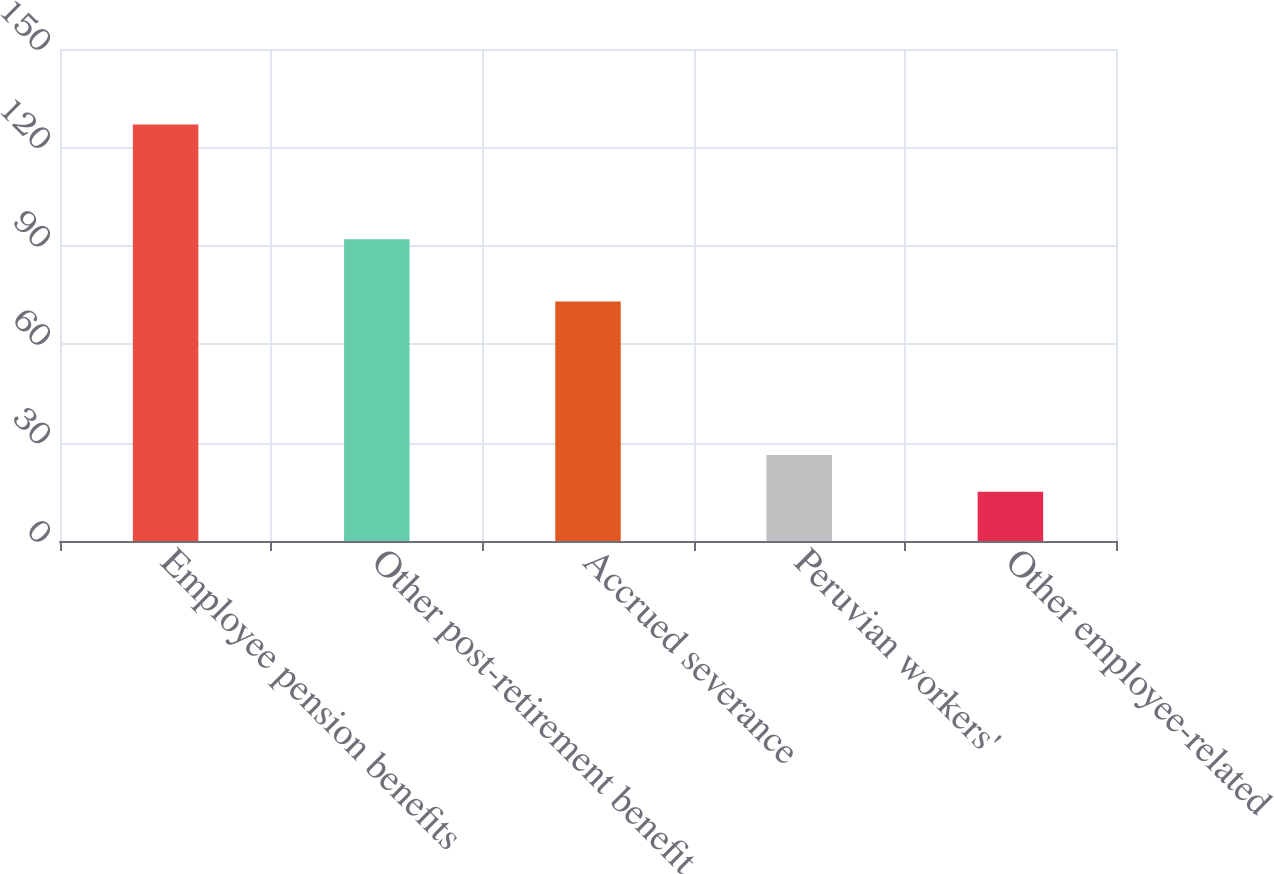Convert chart to OTSL. <chart><loc_0><loc_0><loc_500><loc_500><bar_chart><fcel>Employee pension benefits<fcel>Other post-retirement benefit<fcel>Accrued severance<fcel>Peruvian workers'<fcel>Other employee-related<nl><fcel>127<fcel>92<fcel>73<fcel>26.2<fcel>15<nl></chart> 